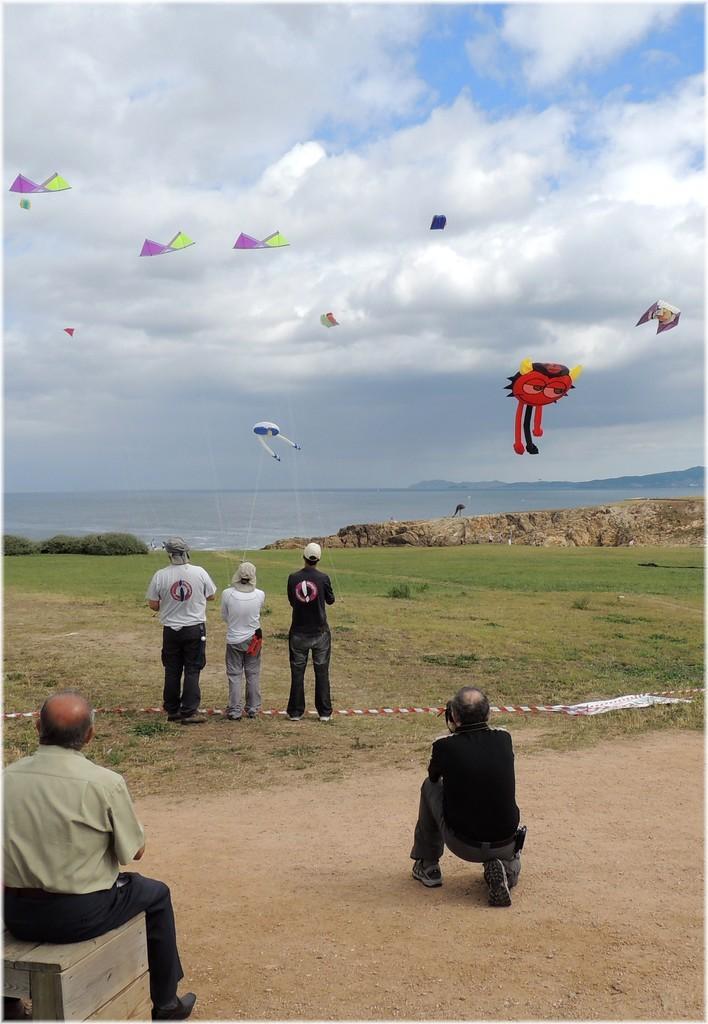In one or two sentences, can you explain what this image depicts? In this image in the front there are persons sitting. In the center there are persons standing and flying kites and there's grass on the ground. In the background there is water and the sky is cloudy and there are kites flying in the sky. 